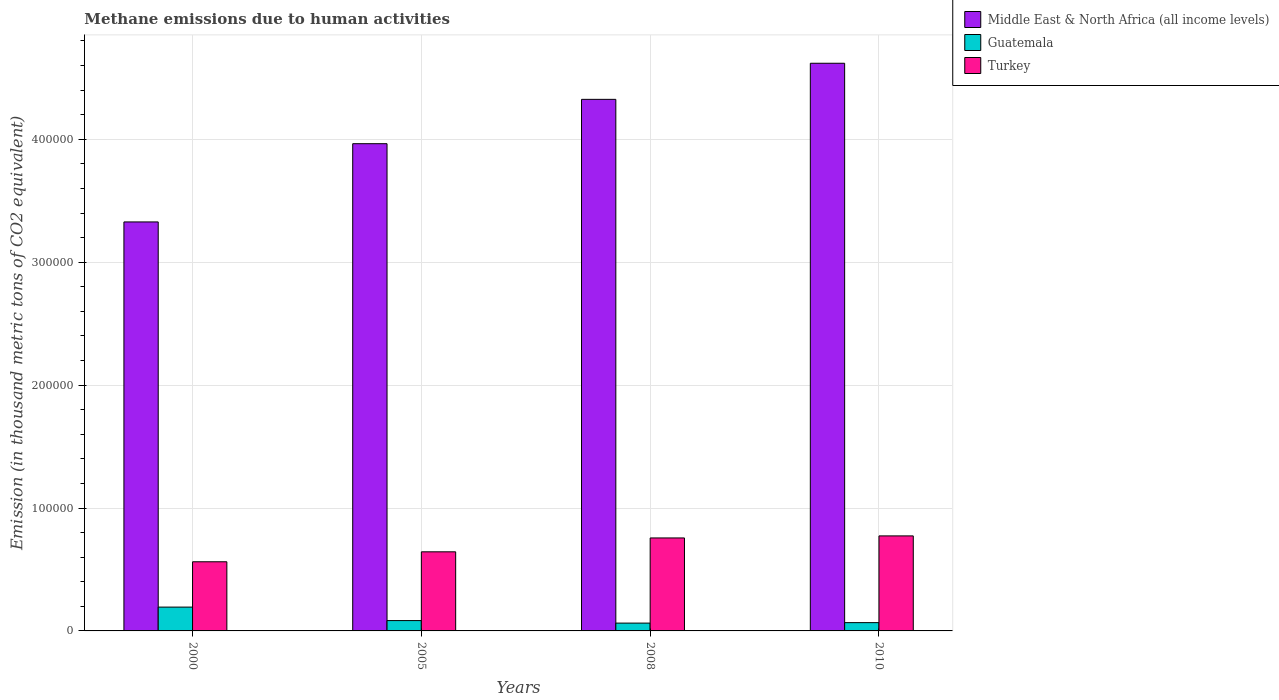How many different coloured bars are there?
Keep it short and to the point. 3. How many bars are there on the 2nd tick from the left?
Make the answer very short. 3. What is the amount of methane emitted in Guatemala in 2008?
Ensure brevity in your answer.  6365.4. Across all years, what is the maximum amount of methane emitted in Guatemala?
Ensure brevity in your answer.  1.94e+04. Across all years, what is the minimum amount of methane emitted in Guatemala?
Keep it short and to the point. 6365.4. In which year was the amount of methane emitted in Guatemala maximum?
Ensure brevity in your answer.  2000. In which year was the amount of methane emitted in Guatemala minimum?
Your answer should be compact. 2008. What is the total amount of methane emitted in Turkey in the graph?
Your answer should be compact. 2.74e+05. What is the difference between the amount of methane emitted in Turkey in 2000 and that in 2010?
Give a very brief answer. -2.10e+04. What is the difference between the amount of methane emitted in Middle East & North Africa (all income levels) in 2008 and the amount of methane emitted in Guatemala in 2005?
Keep it short and to the point. 4.24e+05. What is the average amount of methane emitted in Middle East & North Africa (all income levels) per year?
Give a very brief answer. 4.06e+05. In the year 2000, what is the difference between the amount of methane emitted in Turkey and amount of methane emitted in Guatemala?
Provide a short and direct response. 3.69e+04. What is the ratio of the amount of methane emitted in Guatemala in 2000 to that in 2010?
Your answer should be very brief. 2.87. Is the amount of methane emitted in Middle East & North Africa (all income levels) in 2000 less than that in 2008?
Ensure brevity in your answer.  Yes. Is the difference between the amount of methane emitted in Turkey in 2000 and 2010 greater than the difference between the amount of methane emitted in Guatemala in 2000 and 2010?
Offer a terse response. No. What is the difference between the highest and the second highest amount of methane emitted in Turkey?
Provide a short and direct response. 1655.4. What is the difference between the highest and the lowest amount of methane emitted in Turkey?
Ensure brevity in your answer.  2.10e+04. Is the sum of the amount of methane emitted in Middle East & North Africa (all income levels) in 2000 and 2005 greater than the maximum amount of methane emitted in Turkey across all years?
Offer a terse response. Yes. What does the 2nd bar from the left in 2010 represents?
Make the answer very short. Guatemala. What does the 2nd bar from the right in 2008 represents?
Your response must be concise. Guatemala. Is it the case that in every year, the sum of the amount of methane emitted in Guatemala and amount of methane emitted in Turkey is greater than the amount of methane emitted in Middle East & North Africa (all income levels)?
Make the answer very short. No. How many bars are there?
Your response must be concise. 12. How many years are there in the graph?
Provide a succinct answer. 4. What is the difference between two consecutive major ticks on the Y-axis?
Ensure brevity in your answer.  1.00e+05. Does the graph contain grids?
Your answer should be compact. Yes. Where does the legend appear in the graph?
Provide a succinct answer. Top right. How many legend labels are there?
Provide a succinct answer. 3. How are the legend labels stacked?
Give a very brief answer. Vertical. What is the title of the graph?
Make the answer very short. Methane emissions due to human activities. What is the label or title of the Y-axis?
Ensure brevity in your answer.  Emission (in thousand metric tons of CO2 equivalent). What is the Emission (in thousand metric tons of CO2 equivalent) in Middle East & North Africa (all income levels) in 2000?
Ensure brevity in your answer.  3.33e+05. What is the Emission (in thousand metric tons of CO2 equivalent) of Guatemala in 2000?
Give a very brief answer. 1.94e+04. What is the Emission (in thousand metric tons of CO2 equivalent) in Turkey in 2000?
Provide a succinct answer. 5.63e+04. What is the Emission (in thousand metric tons of CO2 equivalent) of Middle East & North Africa (all income levels) in 2005?
Ensure brevity in your answer.  3.96e+05. What is the Emission (in thousand metric tons of CO2 equivalent) in Guatemala in 2005?
Provide a succinct answer. 8404.9. What is the Emission (in thousand metric tons of CO2 equivalent) in Turkey in 2005?
Offer a terse response. 6.44e+04. What is the Emission (in thousand metric tons of CO2 equivalent) of Middle East & North Africa (all income levels) in 2008?
Offer a terse response. 4.32e+05. What is the Emission (in thousand metric tons of CO2 equivalent) in Guatemala in 2008?
Keep it short and to the point. 6365.4. What is the Emission (in thousand metric tons of CO2 equivalent) of Turkey in 2008?
Give a very brief answer. 7.57e+04. What is the Emission (in thousand metric tons of CO2 equivalent) in Middle East & North Africa (all income levels) in 2010?
Provide a short and direct response. 4.62e+05. What is the Emission (in thousand metric tons of CO2 equivalent) of Guatemala in 2010?
Keep it short and to the point. 6745.7. What is the Emission (in thousand metric tons of CO2 equivalent) in Turkey in 2010?
Keep it short and to the point. 7.73e+04. Across all years, what is the maximum Emission (in thousand metric tons of CO2 equivalent) in Middle East & North Africa (all income levels)?
Ensure brevity in your answer.  4.62e+05. Across all years, what is the maximum Emission (in thousand metric tons of CO2 equivalent) in Guatemala?
Ensure brevity in your answer.  1.94e+04. Across all years, what is the maximum Emission (in thousand metric tons of CO2 equivalent) of Turkey?
Your response must be concise. 7.73e+04. Across all years, what is the minimum Emission (in thousand metric tons of CO2 equivalent) in Middle East & North Africa (all income levels)?
Keep it short and to the point. 3.33e+05. Across all years, what is the minimum Emission (in thousand metric tons of CO2 equivalent) of Guatemala?
Offer a very short reply. 6365.4. Across all years, what is the minimum Emission (in thousand metric tons of CO2 equivalent) in Turkey?
Provide a succinct answer. 5.63e+04. What is the total Emission (in thousand metric tons of CO2 equivalent) of Middle East & North Africa (all income levels) in the graph?
Provide a short and direct response. 1.62e+06. What is the total Emission (in thousand metric tons of CO2 equivalent) in Guatemala in the graph?
Your answer should be very brief. 4.09e+04. What is the total Emission (in thousand metric tons of CO2 equivalent) in Turkey in the graph?
Give a very brief answer. 2.74e+05. What is the difference between the Emission (in thousand metric tons of CO2 equivalent) in Middle East & North Africa (all income levels) in 2000 and that in 2005?
Provide a short and direct response. -6.37e+04. What is the difference between the Emission (in thousand metric tons of CO2 equivalent) of Guatemala in 2000 and that in 2005?
Offer a terse response. 1.10e+04. What is the difference between the Emission (in thousand metric tons of CO2 equivalent) in Turkey in 2000 and that in 2005?
Offer a very short reply. -8092.9. What is the difference between the Emission (in thousand metric tons of CO2 equivalent) in Middle East & North Africa (all income levels) in 2000 and that in 2008?
Your answer should be compact. -9.97e+04. What is the difference between the Emission (in thousand metric tons of CO2 equivalent) in Guatemala in 2000 and that in 2008?
Keep it short and to the point. 1.30e+04. What is the difference between the Emission (in thousand metric tons of CO2 equivalent) in Turkey in 2000 and that in 2008?
Your response must be concise. -1.94e+04. What is the difference between the Emission (in thousand metric tons of CO2 equivalent) of Middle East & North Africa (all income levels) in 2000 and that in 2010?
Keep it short and to the point. -1.29e+05. What is the difference between the Emission (in thousand metric tons of CO2 equivalent) in Guatemala in 2000 and that in 2010?
Keep it short and to the point. 1.26e+04. What is the difference between the Emission (in thousand metric tons of CO2 equivalent) in Turkey in 2000 and that in 2010?
Keep it short and to the point. -2.10e+04. What is the difference between the Emission (in thousand metric tons of CO2 equivalent) in Middle East & North Africa (all income levels) in 2005 and that in 2008?
Offer a terse response. -3.61e+04. What is the difference between the Emission (in thousand metric tons of CO2 equivalent) in Guatemala in 2005 and that in 2008?
Keep it short and to the point. 2039.5. What is the difference between the Emission (in thousand metric tons of CO2 equivalent) in Turkey in 2005 and that in 2008?
Provide a succinct answer. -1.13e+04. What is the difference between the Emission (in thousand metric tons of CO2 equivalent) of Middle East & North Africa (all income levels) in 2005 and that in 2010?
Give a very brief answer. -6.54e+04. What is the difference between the Emission (in thousand metric tons of CO2 equivalent) of Guatemala in 2005 and that in 2010?
Ensure brevity in your answer.  1659.2. What is the difference between the Emission (in thousand metric tons of CO2 equivalent) in Turkey in 2005 and that in 2010?
Your response must be concise. -1.30e+04. What is the difference between the Emission (in thousand metric tons of CO2 equivalent) in Middle East & North Africa (all income levels) in 2008 and that in 2010?
Give a very brief answer. -2.94e+04. What is the difference between the Emission (in thousand metric tons of CO2 equivalent) in Guatemala in 2008 and that in 2010?
Ensure brevity in your answer.  -380.3. What is the difference between the Emission (in thousand metric tons of CO2 equivalent) of Turkey in 2008 and that in 2010?
Keep it short and to the point. -1655.4. What is the difference between the Emission (in thousand metric tons of CO2 equivalent) in Middle East & North Africa (all income levels) in 2000 and the Emission (in thousand metric tons of CO2 equivalent) in Guatemala in 2005?
Keep it short and to the point. 3.24e+05. What is the difference between the Emission (in thousand metric tons of CO2 equivalent) in Middle East & North Africa (all income levels) in 2000 and the Emission (in thousand metric tons of CO2 equivalent) in Turkey in 2005?
Your answer should be compact. 2.68e+05. What is the difference between the Emission (in thousand metric tons of CO2 equivalent) of Guatemala in 2000 and the Emission (in thousand metric tons of CO2 equivalent) of Turkey in 2005?
Your response must be concise. -4.50e+04. What is the difference between the Emission (in thousand metric tons of CO2 equivalent) of Middle East & North Africa (all income levels) in 2000 and the Emission (in thousand metric tons of CO2 equivalent) of Guatemala in 2008?
Offer a terse response. 3.26e+05. What is the difference between the Emission (in thousand metric tons of CO2 equivalent) in Middle East & North Africa (all income levels) in 2000 and the Emission (in thousand metric tons of CO2 equivalent) in Turkey in 2008?
Keep it short and to the point. 2.57e+05. What is the difference between the Emission (in thousand metric tons of CO2 equivalent) in Guatemala in 2000 and the Emission (in thousand metric tons of CO2 equivalent) in Turkey in 2008?
Your answer should be compact. -5.63e+04. What is the difference between the Emission (in thousand metric tons of CO2 equivalent) in Middle East & North Africa (all income levels) in 2000 and the Emission (in thousand metric tons of CO2 equivalent) in Guatemala in 2010?
Provide a short and direct response. 3.26e+05. What is the difference between the Emission (in thousand metric tons of CO2 equivalent) in Middle East & North Africa (all income levels) in 2000 and the Emission (in thousand metric tons of CO2 equivalent) in Turkey in 2010?
Your response must be concise. 2.55e+05. What is the difference between the Emission (in thousand metric tons of CO2 equivalent) in Guatemala in 2000 and the Emission (in thousand metric tons of CO2 equivalent) in Turkey in 2010?
Keep it short and to the point. -5.79e+04. What is the difference between the Emission (in thousand metric tons of CO2 equivalent) of Middle East & North Africa (all income levels) in 2005 and the Emission (in thousand metric tons of CO2 equivalent) of Guatemala in 2008?
Offer a terse response. 3.90e+05. What is the difference between the Emission (in thousand metric tons of CO2 equivalent) of Middle East & North Africa (all income levels) in 2005 and the Emission (in thousand metric tons of CO2 equivalent) of Turkey in 2008?
Provide a short and direct response. 3.21e+05. What is the difference between the Emission (in thousand metric tons of CO2 equivalent) in Guatemala in 2005 and the Emission (in thousand metric tons of CO2 equivalent) in Turkey in 2008?
Keep it short and to the point. -6.72e+04. What is the difference between the Emission (in thousand metric tons of CO2 equivalent) of Middle East & North Africa (all income levels) in 2005 and the Emission (in thousand metric tons of CO2 equivalent) of Guatemala in 2010?
Offer a terse response. 3.90e+05. What is the difference between the Emission (in thousand metric tons of CO2 equivalent) in Middle East & North Africa (all income levels) in 2005 and the Emission (in thousand metric tons of CO2 equivalent) in Turkey in 2010?
Make the answer very short. 3.19e+05. What is the difference between the Emission (in thousand metric tons of CO2 equivalent) in Guatemala in 2005 and the Emission (in thousand metric tons of CO2 equivalent) in Turkey in 2010?
Provide a short and direct response. -6.89e+04. What is the difference between the Emission (in thousand metric tons of CO2 equivalent) of Middle East & North Africa (all income levels) in 2008 and the Emission (in thousand metric tons of CO2 equivalent) of Guatemala in 2010?
Keep it short and to the point. 4.26e+05. What is the difference between the Emission (in thousand metric tons of CO2 equivalent) of Middle East & North Africa (all income levels) in 2008 and the Emission (in thousand metric tons of CO2 equivalent) of Turkey in 2010?
Give a very brief answer. 3.55e+05. What is the difference between the Emission (in thousand metric tons of CO2 equivalent) in Guatemala in 2008 and the Emission (in thousand metric tons of CO2 equivalent) in Turkey in 2010?
Offer a very short reply. -7.09e+04. What is the average Emission (in thousand metric tons of CO2 equivalent) of Middle East & North Africa (all income levels) per year?
Keep it short and to the point. 4.06e+05. What is the average Emission (in thousand metric tons of CO2 equivalent) in Guatemala per year?
Your response must be concise. 1.02e+04. What is the average Emission (in thousand metric tons of CO2 equivalent) in Turkey per year?
Your response must be concise. 6.84e+04. In the year 2000, what is the difference between the Emission (in thousand metric tons of CO2 equivalent) of Middle East & North Africa (all income levels) and Emission (in thousand metric tons of CO2 equivalent) of Guatemala?
Provide a short and direct response. 3.13e+05. In the year 2000, what is the difference between the Emission (in thousand metric tons of CO2 equivalent) in Middle East & North Africa (all income levels) and Emission (in thousand metric tons of CO2 equivalent) in Turkey?
Keep it short and to the point. 2.76e+05. In the year 2000, what is the difference between the Emission (in thousand metric tons of CO2 equivalent) of Guatemala and Emission (in thousand metric tons of CO2 equivalent) of Turkey?
Ensure brevity in your answer.  -3.69e+04. In the year 2005, what is the difference between the Emission (in thousand metric tons of CO2 equivalent) of Middle East & North Africa (all income levels) and Emission (in thousand metric tons of CO2 equivalent) of Guatemala?
Your answer should be compact. 3.88e+05. In the year 2005, what is the difference between the Emission (in thousand metric tons of CO2 equivalent) of Middle East & North Africa (all income levels) and Emission (in thousand metric tons of CO2 equivalent) of Turkey?
Offer a terse response. 3.32e+05. In the year 2005, what is the difference between the Emission (in thousand metric tons of CO2 equivalent) of Guatemala and Emission (in thousand metric tons of CO2 equivalent) of Turkey?
Offer a terse response. -5.60e+04. In the year 2008, what is the difference between the Emission (in thousand metric tons of CO2 equivalent) in Middle East & North Africa (all income levels) and Emission (in thousand metric tons of CO2 equivalent) in Guatemala?
Make the answer very short. 4.26e+05. In the year 2008, what is the difference between the Emission (in thousand metric tons of CO2 equivalent) of Middle East & North Africa (all income levels) and Emission (in thousand metric tons of CO2 equivalent) of Turkey?
Make the answer very short. 3.57e+05. In the year 2008, what is the difference between the Emission (in thousand metric tons of CO2 equivalent) in Guatemala and Emission (in thousand metric tons of CO2 equivalent) in Turkey?
Your response must be concise. -6.93e+04. In the year 2010, what is the difference between the Emission (in thousand metric tons of CO2 equivalent) of Middle East & North Africa (all income levels) and Emission (in thousand metric tons of CO2 equivalent) of Guatemala?
Provide a succinct answer. 4.55e+05. In the year 2010, what is the difference between the Emission (in thousand metric tons of CO2 equivalent) of Middle East & North Africa (all income levels) and Emission (in thousand metric tons of CO2 equivalent) of Turkey?
Your answer should be compact. 3.85e+05. In the year 2010, what is the difference between the Emission (in thousand metric tons of CO2 equivalent) of Guatemala and Emission (in thousand metric tons of CO2 equivalent) of Turkey?
Offer a terse response. -7.06e+04. What is the ratio of the Emission (in thousand metric tons of CO2 equivalent) in Middle East & North Africa (all income levels) in 2000 to that in 2005?
Offer a very short reply. 0.84. What is the ratio of the Emission (in thousand metric tons of CO2 equivalent) in Guatemala in 2000 to that in 2005?
Give a very brief answer. 2.31. What is the ratio of the Emission (in thousand metric tons of CO2 equivalent) in Turkey in 2000 to that in 2005?
Keep it short and to the point. 0.87. What is the ratio of the Emission (in thousand metric tons of CO2 equivalent) in Middle East & North Africa (all income levels) in 2000 to that in 2008?
Provide a succinct answer. 0.77. What is the ratio of the Emission (in thousand metric tons of CO2 equivalent) in Guatemala in 2000 to that in 2008?
Offer a terse response. 3.05. What is the ratio of the Emission (in thousand metric tons of CO2 equivalent) in Turkey in 2000 to that in 2008?
Offer a terse response. 0.74. What is the ratio of the Emission (in thousand metric tons of CO2 equivalent) in Middle East & North Africa (all income levels) in 2000 to that in 2010?
Your answer should be very brief. 0.72. What is the ratio of the Emission (in thousand metric tons of CO2 equivalent) in Guatemala in 2000 to that in 2010?
Your response must be concise. 2.87. What is the ratio of the Emission (in thousand metric tons of CO2 equivalent) of Turkey in 2000 to that in 2010?
Offer a very short reply. 0.73. What is the ratio of the Emission (in thousand metric tons of CO2 equivalent) of Middle East & North Africa (all income levels) in 2005 to that in 2008?
Provide a succinct answer. 0.92. What is the ratio of the Emission (in thousand metric tons of CO2 equivalent) in Guatemala in 2005 to that in 2008?
Offer a terse response. 1.32. What is the ratio of the Emission (in thousand metric tons of CO2 equivalent) of Turkey in 2005 to that in 2008?
Provide a succinct answer. 0.85. What is the ratio of the Emission (in thousand metric tons of CO2 equivalent) of Middle East & North Africa (all income levels) in 2005 to that in 2010?
Your answer should be compact. 0.86. What is the ratio of the Emission (in thousand metric tons of CO2 equivalent) of Guatemala in 2005 to that in 2010?
Your response must be concise. 1.25. What is the ratio of the Emission (in thousand metric tons of CO2 equivalent) of Turkey in 2005 to that in 2010?
Provide a short and direct response. 0.83. What is the ratio of the Emission (in thousand metric tons of CO2 equivalent) of Middle East & North Africa (all income levels) in 2008 to that in 2010?
Make the answer very short. 0.94. What is the ratio of the Emission (in thousand metric tons of CO2 equivalent) of Guatemala in 2008 to that in 2010?
Give a very brief answer. 0.94. What is the ratio of the Emission (in thousand metric tons of CO2 equivalent) of Turkey in 2008 to that in 2010?
Your answer should be very brief. 0.98. What is the difference between the highest and the second highest Emission (in thousand metric tons of CO2 equivalent) in Middle East & North Africa (all income levels)?
Provide a succinct answer. 2.94e+04. What is the difference between the highest and the second highest Emission (in thousand metric tons of CO2 equivalent) in Guatemala?
Offer a very short reply. 1.10e+04. What is the difference between the highest and the second highest Emission (in thousand metric tons of CO2 equivalent) of Turkey?
Provide a short and direct response. 1655.4. What is the difference between the highest and the lowest Emission (in thousand metric tons of CO2 equivalent) in Middle East & North Africa (all income levels)?
Your response must be concise. 1.29e+05. What is the difference between the highest and the lowest Emission (in thousand metric tons of CO2 equivalent) of Guatemala?
Your response must be concise. 1.30e+04. What is the difference between the highest and the lowest Emission (in thousand metric tons of CO2 equivalent) in Turkey?
Give a very brief answer. 2.10e+04. 